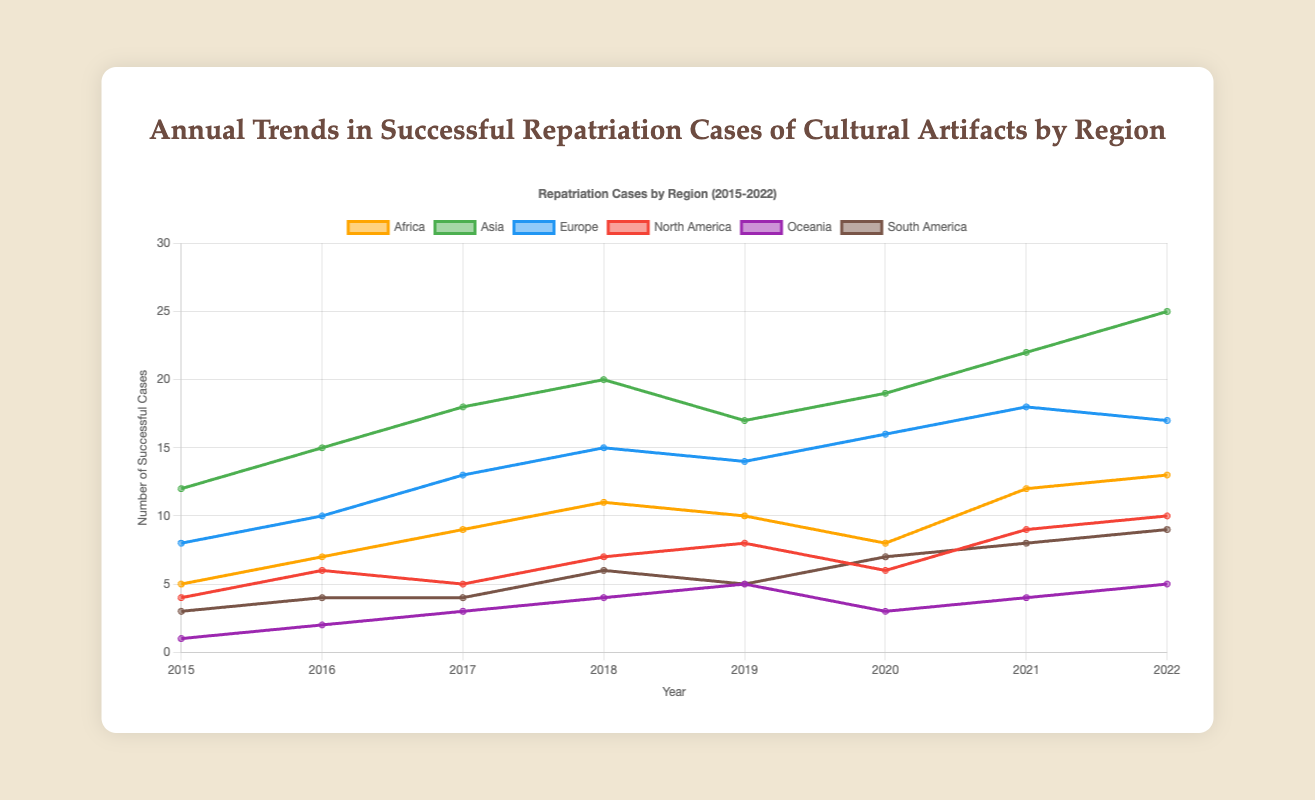What region had the highest number of successful repatriation cases in 2022? The line plot shows the number of successful repatriation cases on the y-axis and the respective year on the x-axis for different regions. In 2022, the line for Asia is the highest on the y-axis, indicating that Asia had the most successful repatriation cases
Answer: Asia How did the number of successful repatriation cases in Oceania change from 2015 to 2022? To determine this, check the y-values of the Oceania line at the points corresponding to 2015 and 2022. In 2015, Oceania had 1 case and in 2022, it had 5 cases. Thus, the cases increased by (5 - 1) = 4.
Answer: Increased by 4 Which region showed the greatest increase in successful repatriation cases from 2015 to 2022? Calculate the increase for each region by subtracting the number of cases in 2015 from 2022. The differences are: Africa (13 - 5 = 8), Asia (25 - 12 = 13), Europe (17 - 8 = 9), North America (10 - 4 = 6), Oceania (5 - 1 = 4), South America (9 - 3 = 6). Asia had the greatest increase of 13 cases.
Answer: Asia In which year did Africa have the lowest number of successful repatriation cases? The line for Africa is at its lowest y-value in 2015.
Answer: 2015 Compare the number of successful repatriation cases in Europe and North America in 2020. Which was higher? By looking at the y-values for Europe and North America in 2020, Europe had 16 and North America had 6. Therefore, Europe had more cases.
Answer: Europe What was the combined number of successful repatriation cases for Africa and Asia in 2017? Add the y-values for Africa and Asia in 2017: Africa (9) + Asia (18) = 27
Answer: 27 What is the range of the number of successful repatriation cases for South America from 2015 to 2022? Determine the maximum and minimum values for the South America line between 2015 and 2022. The maximum is 9 in 2022 and the minimum is 3 in 2015. The range is 9 - 3 = 6
Answer: 6 Explain the trend in successful repatriation cases in Asia from 2015 to 2022. The line for Asia shows an overall increasing trend. In detail, the number of cases starts at 12 in 2015, increases consistently every year except for a slight drop in 2019, and reaches a peak of 25 in 2022.
Answer: Increasing trend Which region showed the smallest relative increase from 2015 to 2022? Calculate the relative increase for each region: (Cases in 2022 - Cases in 2015) / Cases in 2015 * 100%. Africa: (13-5)/5*100%=160%, Asia: (25-12)/12*100%=108.3%, Europe: (17-8)/8*100%=112.5%, North America: (10-4)/4*100%=150%, Oceania: (5-1)/1*100%=400%, South America: (9-3)/3*100%=200%. Asia had the smallest relative increase of 108.3%
Answer: Asia 